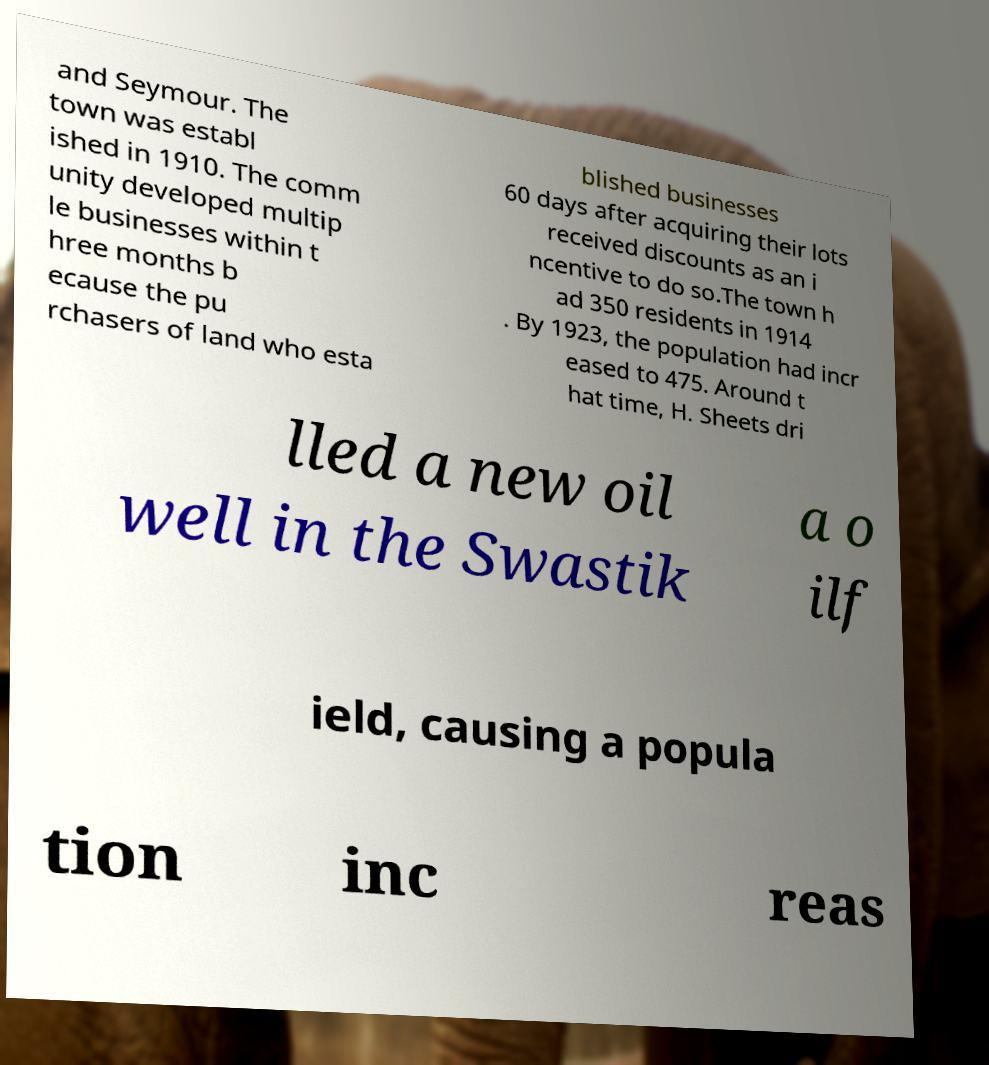Could you assist in decoding the text presented in this image and type it out clearly? and Seymour. The town was establ ished in 1910. The comm unity developed multip le businesses within t hree months b ecause the pu rchasers of land who esta blished businesses 60 days after acquiring their lots received discounts as an i ncentive to do so.The town h ad 350 residents in 1914 . By 1923, the population had incr eased to 475. Around t hat time, H. Sheets dri lled a new oil well in the Swastik a o ilf ield, causing a popula tion inc reas 